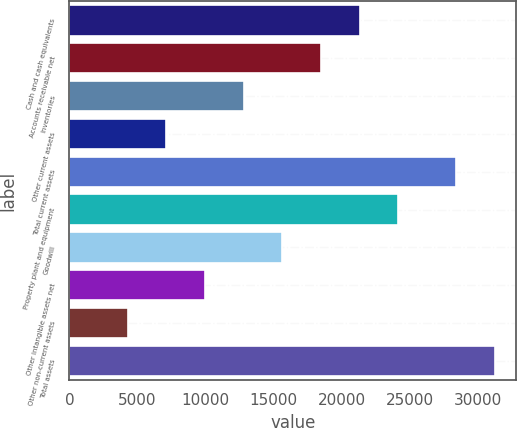Convert chart to OTSL. <chart><loc_0><loc_0><loc_500><loc_500><bar_chart><fcel>Cash and cash equivalents<fcel>Accounts receivable net<fcel>Inventories<fcel>Other current assets<fcel>Total current assets<fcel>Property plant and equipment<fcel>Goodwill<fcel>Other intangible assets net<fcel>Other non-current assets<fcel>Total assets<nl><fcel>21307.5<fcel>18466.9<fcel>12785.7<fcel>7104.5<fcel>28409<fcel>24148.1<fcel>15626.3<fcel>9945.1<fcel>4263.9<fcel>31249.6<nl></chart> 